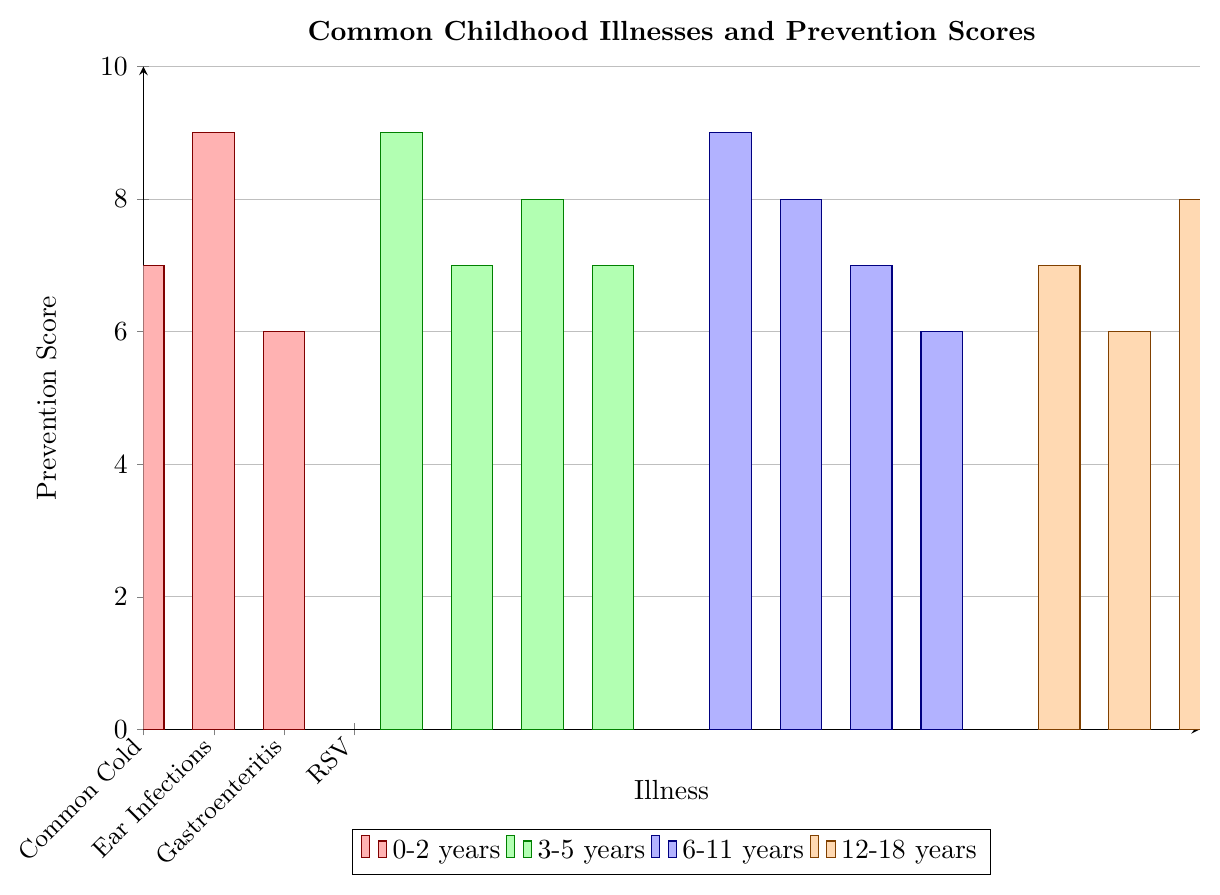What's the illness with the highest prevention score in the 0-2 years age group? Look at the first set of bars representing the 0-2 years age group. The tallest bar is for Gastroenteritis with a score of 9.
Answer: Gastroenteritis Which age group has the lowest prevention score for any illness? Find the shortest bar in each set. The shortest bar overall is for Respiratory Syncytial Virus (RSV) in the 0-2 years age group and Mononucleosis in the 12-18 years age group, both with a score of 6.
Answer: 0-2 years and 12-18 years What is the sum of the prevention scores for illnesses in the 6-11 years age group? Identify the scores for the 6-11 years age group: Influenza (9), Asthma (8), Food Allergies (7), Lice (6). Sum these: 9 + 8 + 7 + 6 = 30.
Answer: 30 Which illness has a prevention score of 7 in the 12-18 years age group? Look at the bars in the 12-18 years age group. The illnesses with a score of 7 are Acne and Sports Injuries.
Answer: Acne and Sports Injuries Is the prevention score for Chickenpox higher or lower than the score for Pink Eye? Compare the bars for Chickenpox (9) and Pink Eye (8) in the 3-5 years age group. Chickenpox has a higher score.
Answer: Higher What is the average prevention score for the illnesses in the 3-5 years age group? Identify the scores for the 3-5 years age group: Chickenpox (9), Strep Throat (7), Pink Eye (8), Hand Foot and Mouth Disease (7). Sum and divide by 4: (9 + 7 + 8 + 7)/4 = 7.75.
Answer: 7.75 Which age group has the most illnesses with a prevention score of 7? Count how many bars have a score of 7 in each age group. The 0-2 years and 3-5 years age groups both have one illness with a score of 7, while the 12-18 years age group has two.
Answer: 12-18 years 